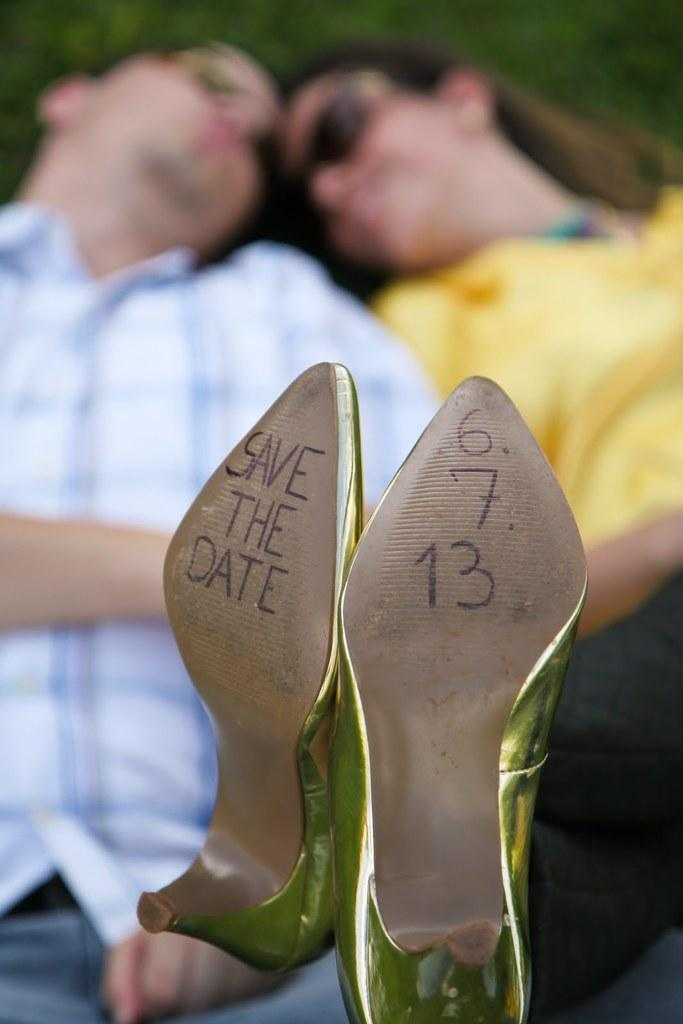What is located in the middle of the image? There are shoes in the middle of the image. What can be seen in the background of the image? There is a man and a woman in the background of the image. What is written or printed on the shoes? There is text on the shoes. What type of canvas can be seen in the image? There is no canvas present in the image. What kind of waves can be seen in the image? There are no waves present in the image. 